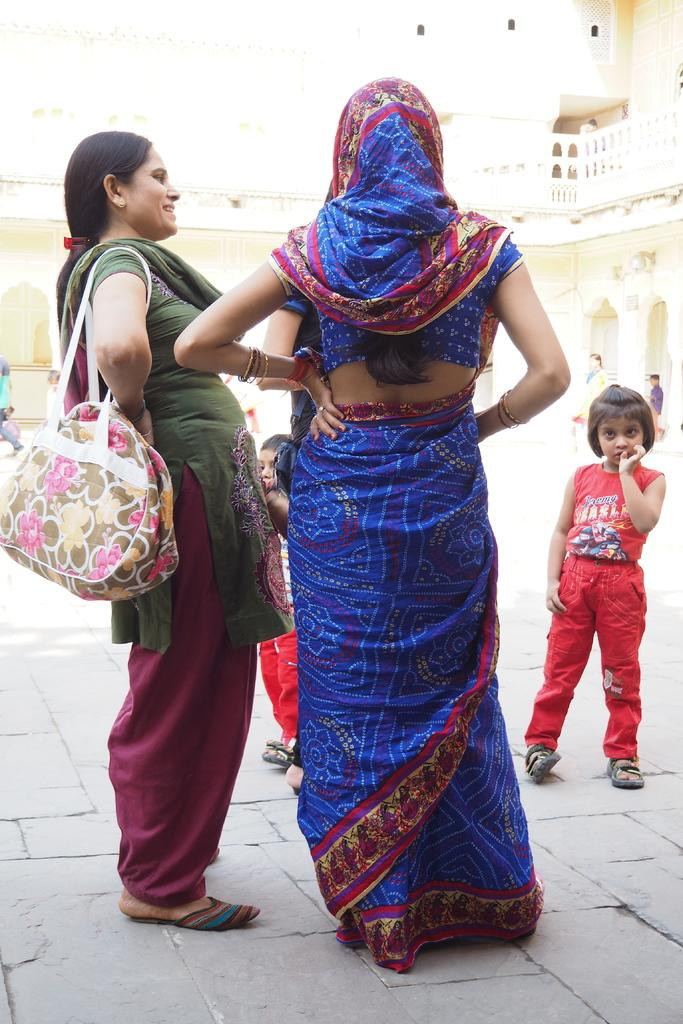How many women are in the image? There are two women in the image. What is one of the women doing with her hands? One of the women is holding a bag on her shoulders. What is the child's posture in the image? The child is standing in the image. What can be seen in the background of the image? There is a building in the background of the image. What type of science experiment is being conducted by the women in the image? There is no indication of a science experiment being conducted in the image. 